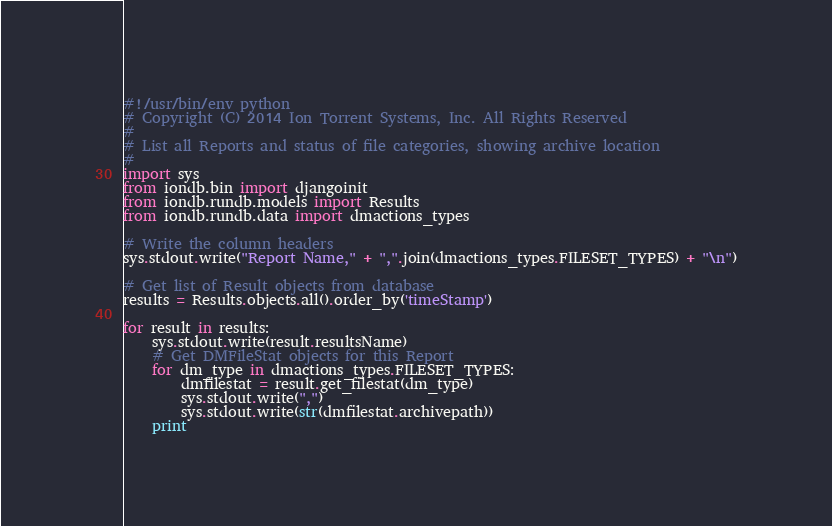<code> <loc_0><loc_0><loc_500><loc_500><_Python_>#!/usr/bin/env python
# Copyright (C) 2014 Ion Torrent Systems, Inc. All Rights Reserved
#
# List all Reports and status of file categories, showing archive location
#
import sys
from iondb.bin import djangoinit
from iondb.rundb.models import Results
from iondb.rundb.data import dmactions_types

# Write the column headers
sys.stdout.write("Report Name," + ",".join(dmactions_types.FILESET_TYPES) + "\n")

# Get list of Result objects from database
results = Results.objects.all().order_by('timeStamp')

for result in results:
    sys.stdout.write(result.resultsName)
    # Get DMFileStat objects for this Report
    for dm_type in dmactions_types.FILESET_TYPES:
        dmfilestat = result.get_filestat(dm_type)
        sys.stdout.write(",")
        sys.stdout.write(str(dmfilestat.archivepath))
    print
</code> 